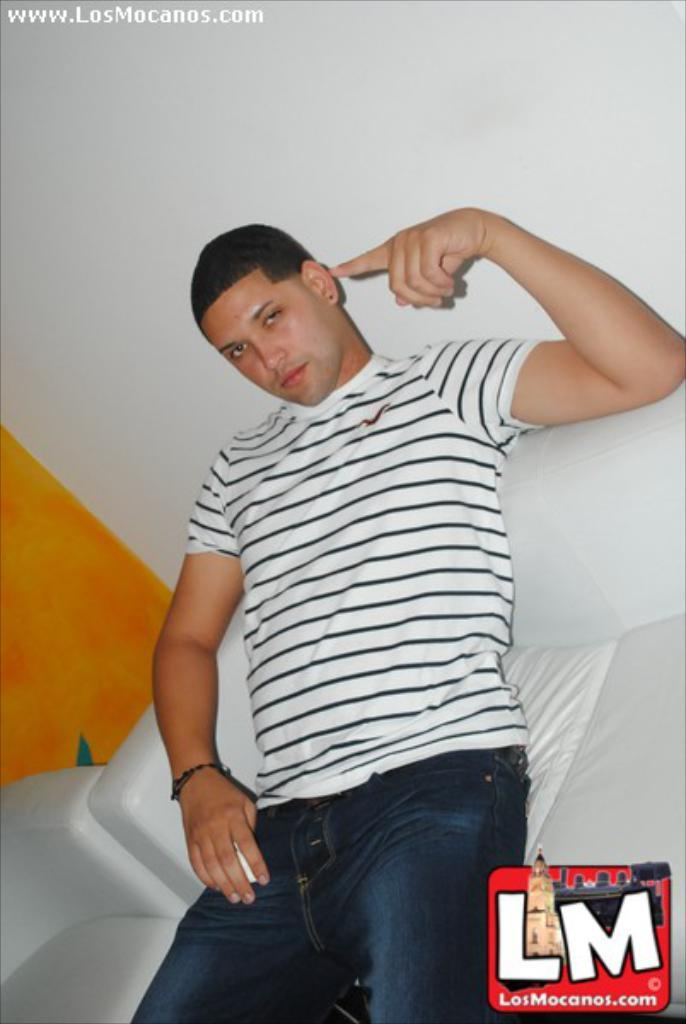Who is present in the image? There is a man in the image. What type of clothing is the man wearing? The man is wearing blue jeans and a white T-shirt. What is the background of the image? There is a wall at the top of the image. Where is the man sitting in the image? The man is sitting on a sofa. What type of basin can be seen in the image? There is no basin present in the image. How many rooms are visible in the image? The image only shows one room, as it features a man sitting on a sofa in front of a wall. 